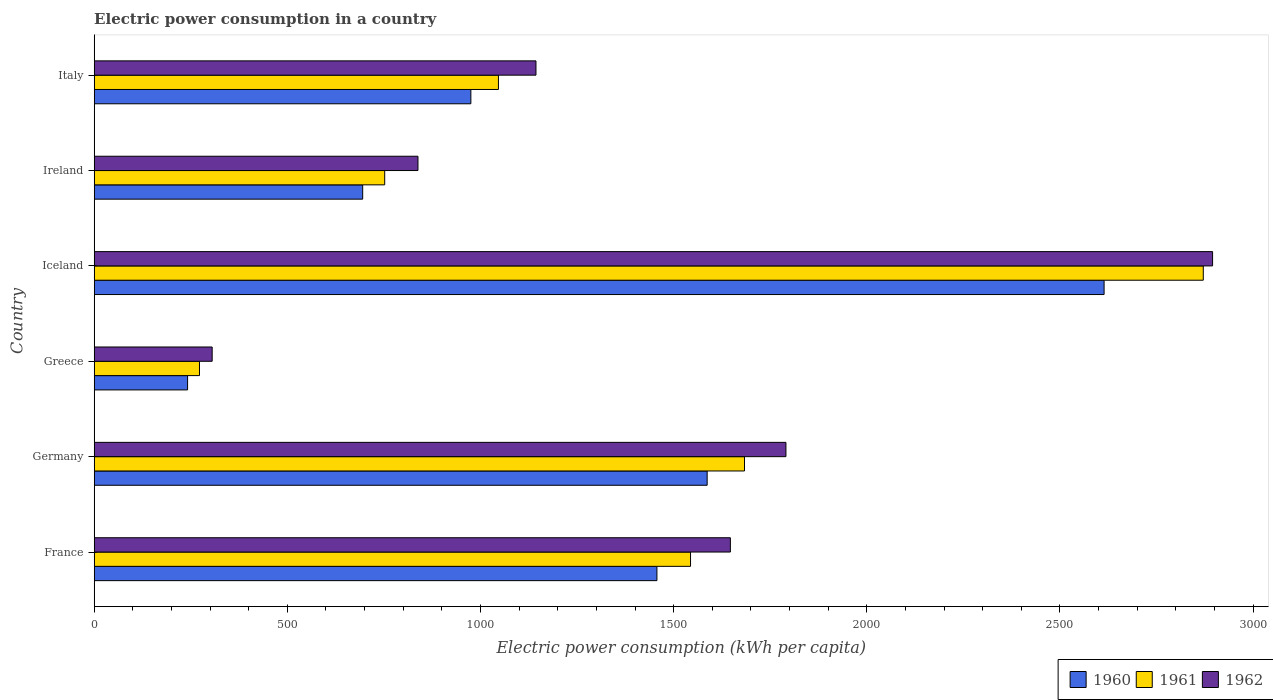How many different coloured bars are there?
Provide a short and direct response. 3. How many groups of bars are there?
Provide a succinct answer. 6. Are the number of bars per tick equal to the number of legend labels?
Offer a very short reply. Yes. How many bars are there on the 3rd tick from the top?
Give a very brief answer. 3. In how many cases, is the number of bars for a given country not equal to the number of legend labels?
Provide a short and direct response. 0. What is the electric power consumption in in 1962 in Italy?
Provide a short and direct response. 1143.61. Across all countries, what is the maximum electric power consumption in in 1961?
Your answer should be compact. 2871.04. Across all countries, what is the minimum electric power consumption in in 1960?
Make the answer very short. 241.73. In which country was the electric power consumption in in 1960 maximum?
Provide a short and direct response. Iceland. In which country was the electric power consumption in in 1961 minimum?
Give a very brief answer. Greece. What is the total electric power consumption in in 1960 in the graph?
Make the answer very short. 7569.52. What is the difference between the electric power consumption in in 1962 in Iceland and that in Italy?
Provide a short and direct response. 1751.48. What is the difference between the electric power consumption in in 1960 in Iceland and the electric power consumption in in 1962 in France?
Your answer should be very brief. 967.45. What is the average electric power consumption in in 1961 per country?
Your answer should be compact. 1361.53. What is the difference between the electric power consumption in in 1962 and electric power consumption in in 1960 in Iceland?
Provide a succinct answer. 280.8. What is the ratio of the electric power consumption in in 1961 in Greece to that in Ireland?
Keep it short and to the point. 0.36. Is the electric power consumption in in 1960 in Greece less than that in Ireland?
Give a very brief answer. Yes. What is the difference between the highest and the second highest electric power consumption in in 1962?
Keep it short and to the point. 1104.4. What is the difference between the highest and the lowest electric power consumption in in 1961?
Give a very brief answer. 2598.48. Is the sum of the electric power consumption in in 1961 in Iceland and Ireland greater than the maximum electric power consumption in in 1960 across all countries?
Provide a short and direct response. Yes. What does the 1st bar from the bottom in Italy represents?
Give a very brief answer. 1960. Is it the case that in every country, the sum of the electric power consumption in in 1960 and electric power consumption in in 1961 is greater than the electric power consumption in in 1962?
Give a very brief answer. Yes. How many bars are there?
Your answer should be very brief. 18. Are all the bars in the graph horizontal?
Your answer should be compact. Yes. How many countries are there in the graph?
Ensure brevity in your answer.  6. Does the graph contain any zero values?
Your response must be concise. No. How many legend labels are there?
Your answer should be compact. 3. What is the title of the graph?
Offer a terse response. Electric power consumption in a country. What is the label or title of the X-axis?
Your answer should be very brief. Electric power consumption (kWh per capita). What is the label or title of the Y-axis?
Make the answer very short. Country. What is the Electric power consumption (kWh per capita) in 1960 in France?
Give a very brief answer. 1456.69. What is the Electric power consumption (kWh per capita) in 1961 in France?
Make the answer very short. 1543.71. What is the Electric power consumption (kWh per capita) in 1962 in France?
Ensure brevity in your answer.  1646.83. What is the Electric power consumption (kWh per capita) in 1960 in Germany?
Offer a terse response. 1586.75. What is the Electric power consumption (kWh per capita) of 1961 in Germany?
Make the answer very short. 1683.41. What is the Electric power consumption (kWh per capita) in 1962 in Germany?
Give a very brief answer. 1790.69. What is the Electric power consumption (kWh per capita) in 1960 in Greece?
Your response must be concise. 241.73. What is the Electric power consumption (kWh per capita) of 1961 in Greece?
Your answer should be very brief. 272.56. What is the Electric power consumption (kWh per capita) of 1962 in Greece?
Your response must be concise. 305.39. What is the Electric power consumption (kWh per capita) in 1960 in Iceland?
Provide a short and direct response. 2614.28. What is the Electric power consumption (kWh per capita) of 1961 in Iceland?
Provide a short and direct response. 2871.04. What is the Electric power consumption (kWh per capita) in 1962 in Iceland?
Make the answer very short. 2895.09. What is the Electric power consumption (kWh per capita) in 1960 in Ireland?
Ensure brevity in your answer.  695.04. What is the Electric power consumption (kWh per capita) of 1961 in Ireland?
Keep it short and to the point. 752.02. What is the Electric power consumption (kWh per capita) in 1962 in Ireland?
Provide a short and direct response. 838.14. What is the Electric power consumption (kWh per capita) of 1960 in Italy?
Provide a short and direct response. 975.03. What is the Electric power consumption (kWh per capita) in 1961 in Italy?
Your answer should be compact. 1046.42. What is the Electric power consumption (kWh per capita) of 1962 in Italy?
Provide a succinct answer. 1143.61. Across all countries, what is the maximum Electric power consumption (kWh per capita) of 1960?
Offer a very short reply. 2614.28. Across all countries, what is the maximum Electric power consumption (kWh per capita) in 1961?
Ensure brevity in your answer.  2871.04. Across all countries, what is the maximum Electric power consumption (kWh per capita) of 1962?
Your answer should be compact. 2895.09. Across all countries, what is the minimum Electric power consumption (kWh per capita) of 1960?
Provide a succinct answer. 241.73. Across all countries, what is the minimum Electric power consumption (kWh per capita) in 1961?
Your response must be concise. 272.56. Across all countries, what is the minimum Electric power consumption (kWh per capita) in 1962?
Offer a terse response. 305.39. What is the total Electric power consumption (kWh per capita) in 1960 in the graph?
Your answer should be compact. 7569.52. What is the total Electric power consumption (kWh per capita) of 1961 in the graph?
Provide a succinct answer. 8169.17. What is the total Electric power consumption (kWh per capita) of 1962 in the graph?
Your answer should be very brief. 8619.74. What is the difference between the Electric power consumption (kWh per capita) in 1960 in France and that in Germany?
Your response must be concise. -130.06. What is the difference between the Electric power consumption (kWh per capita) in 1961 in France and that in Germany?
Your response must be concise. -139.7. What is the difference between the Electric power consumption (kWh per capita) of 1962 in France and that in Germany?
Offer a very short reply. -143.85. What is the difference between the Electric power consumption (kWh per capita) in 1960 in France and that in Greece?
Ensure brevity in your answer.  1214.97. What is the difference between the Electric power consumption (kWh per capita) of 1961 in France and that in Greece?
Offer a terse response. 1271.15. What is the difference between the Electric power consumption (kWh per capita) in 1962 in France and that in Greece?
Your response must be concise. 1341.44. What is the difference between the Electric power consumption (kWh per capita) of 1960 in France and that in Iceland?
Give a very brief answer. -1157.59. What is the difference between the Electric power consumption (kWh per capita) of 1961 in France and that in Iceland?
Provide a succinct answer. -1327.33. What is the difference between the Electric power consumption (kWh per capita) of 1962 in France and that in Iceland?
Give a very brief answer. -1248.25. What is the difference between the Electric power consumption (kWh per capita) in 1960 in France and that in Ireland?
Give a very brief answer. 761.65. What is the difference between the Electric power consumption (kWh per capita) of 1961 in France and that in Ireland?
Provide a succinct answer. 791.69. What is the difference between the Electric power consumption (kWh per capita) in 1962 in France and that in Ireland?
Provide a short and direct response. 808.69. What is the difference between the Electric power consumption (kWh per capita) in 1960 in France and that in Italy?
Make the answer very short. 481.67. What is the difference between the Electric power consumption (kWh per capita) in 1961 in France and that in Italy?
Your answer should be very brief. 497.3. What is the difference between the Electric power consumption (kWh per capita) of 1962 in France and that in Italy?
Offer a very short reply. 503.23. What is the difference between the Electric power consumption (kWh per capita) of 1960 in Germany and that in Greece?
Offer a terse response. 1345.02. What is the difference between the Electric power consumption (kWh per capita) of 1961 in Germany and that in Greece?
Make the answer very short. 1410.85. What is the difference between the Electric power consumption (kWh per capita) of 1962 in Germany and that in Greece?
Provide a short and direct response. 1485.3. What is the difference between the Electric power consumption (kWh per capita) in 1960 in Germany and that in Iceland?
Make the answer very short. -1027.53. What is the difference between the Electric power consumption (kWh per capita) of 1961 in Germany and that in Iceland?
Keep it short and to the point. -1187.63. What is the difference between the Electric power consumption (kWh per capita) in 1962 in Germany and that in Iceland?
Give a very brief answer. -1104.4. What is the difference between the Electric power consumption (kWh per capita) in 1960 in Germany and that in Ireland?
Provide a short and direct response. 891.71. What is the difference between the Electric power consumption (kWh per capita) of 1961 in Germany and that in Ireland?
Give a very brief answer. 931.4. What is the difference between the Electric power consumption (kWh per capita) in 1962 in Germany and that in Ireland?
Make the answer very short. 952.55. What is the difference between the Electric power consumption (kWh per capita) of 1960 in Germany and that in Italy?
Ensure brevity in your answer.  611.72. What is the difference between the Electric power consumption (kWh per capita) in 1961 in Germany and that in Italy?
Your response must be concise. 637. What is the difference between the Electric power consumption (kWh per capita) in 1962 in Germany and that in Italy?
Your response must be concise. 647.08. What is the difference between the Electric power consumption (kWh per capita) of 1960 in Greece and that in Iceland?
Your answer should be compact. -2372.56. What is the difference between the Electric power consumption (kWh per capita) in 1961 in Greece and that in Iceland?
Provide a short and direct response. -2598.48. What is the difference between the Electric power consumption (kWh per capita) of 1962 in Greece and that in Iceland?
Ensure brevity in your answer.  -2589.7. What is the difference between the Electric power consumption (kWh per capita) of 1960 in Greece and that in Ireland?
Offer a very short reply. -453.32. What is the difference between the Electric power consumption (kWh per capita) in 1961 in Greece and that in Ireland?
Offer a very short reply. -479.45. What is the difference between the Electric power consumption (kWh per capita) in 1962 in Greece and that in Ireland?
Your answer should be very brief. -532.75. What is the difference between the Electric power consumption (kWh per capita) in 1960 in Greece and that in Italy?
Offer a terse response. -733.3. What is the difference between the Electric power consumption (kWh per capita) of 1961 in Greece and that in Italy?
Give a very brief answer. -773.85. What is the difference between the Electric power consumption (kWh per capita) in 1962 in Greece and that in Italy?
Ensure brevity in your answer.  -838.22. What is the difference between the Electric power consumption (kWh per capita) in 1960 in Iceland and that in Ireland?
Your response must be concise. 1919.24. What is the difference between the Electric power consumption (kWh per capita) of 1961 in Iceland and that in Ireland?
Keep it short and to the point. 2119.03. What is the difference between the Electric power consumption (kWh per capita) of 1962 in Iceland and that in Ireland?
Your response must be concise. 2056.95. What is the difference between the Electric power consumption (kWh per capita) in 1960 in Iceland and that in Italy?
Give a very brief answer. 1639.26. What is the difference between the Electric power consumption (kWh per capita) of 1961 in Iceland and that in Italy?
Offer a very short reply. 1824.63. What is the difference between the Electric power consumption (kWh per capita) in 1962 in Iceland and that in Italy?
Your response must be concise. 1751.48. What is the difference between the Electric power consumption (kWh per capita) in 1960 in Ireland and that in Italy?
Your response must be concise. -279.98. What is the difference between the Electric power consumption (kWh per capita) of 1961 in Ireland and that in Italy?
Provide a succinct answer. -294.4. What is the difference between the Electric power consumption (kWh per capita) in 1962 in Ireland and that in Italy?
Your response must be concise. -305.47. What is the difference between the Electric power consumption (kWh per capita) of 1960 in France and the Electric power consumption (kWh per capita) of 1961 in Germany?
Offer a terse response. -226.72. What is the difference between the Electric power consumption (kWh per capita) of 1960 in France and the Electric power consumption (kWh per capita) of 1962 in Germany?
Give a very brief answer. -333.99. What is the difference between the Electric power consumption (kWh per capita) in 1961 in France and the Electric power consumption (kWh per capita) in 1962 in Germany?
Make the answer very short. -246.98. What is the difference between the Electric power consumption (kWh per capita) of 1960 in France and the Electric power consumption (kWh per capita) of 1961 in Greece?
Offer a terse response. 1184.13. What is the difference between the Electric power consumption (kWh per capita) in 1960 in France and the Electric power consumption (kWh per capita) in 1962 in Greece?
Make the answer very short. 1151.3. What is the difference between the Electric power consumption (kWh per capita) in 1961 in France and the Electric power consumption (kWh per capita) in 1962 in Greece?
Offer a very short reply. 1238.32. What is the difference between the Electric power consumption (kWh per capita) of 1960 in France and the Electric power consumption (kWh per capita) of 1961 in Iceland?
Keep it short and to the point. -1414.35. What is the difference between the Electric power consumption (kWh per capita) of 1960 in France and the Electric power consumption (kWh per capita) of 1962 in Iceland?
Ensure brevity in your answer.  -1438.39. What is the difference between the Electric power consumption (kWh per capita) of 1961 in France and the Electric power consumption (kWh per capita) of 1962 in Iceland?
Offer a very short reply. -1351.37. What is the difference between the Electric power consumption (kWh per capita) in 1960 in France and the Electric power consumption (kWh per capita) in 1961 in Ireland?
Ensure brevity in your answer.  704.68. What is the difference between the Electric power consumption (kWh per capita) in 1960 in France and the Electric power consumption (kWh per capita) in 1962 in Ireland?
Give a very brief answer. 618.56. What is the difference between the Electric power consumption (kWh per capita) of 1961 in France and the Electric power consumption (kWh per capita) of 1962 in Ireland?
Provide a short and direct response. 705.57. What is the difference between the Electric power consumption (kWh per capita) in 1960 in France and the Electric power consumption (kWh per capita) in 1961 in Italy?
Make the answer very short. 410.28. What is the difference between the Electric power consumption (kWh per capita) of 1960 in France and the Electric power consumption (kWh per capita) of 1962 in Italy?
Your answer should be very brief. 313.09. What is the difference between the Electric power consumption (kWh per capita) in 1961 in France and the Electric power consumption (kWh per capita) in 1962 in Italy?
Your answer should be compact. 400.11. What is the difference between the Electric power consumption (kWh per capita) in 1960 in Germany and the Electric power consumption (kWh per capita) in 1961 in Greece?
Provide a short and direct response. 1314.19. What is the difference between the Electric power consumption (kWh per capita) in 1960 in Germany and the Electric power consumption (kWh per capita) in 1962 in Greece?
Offer a very short reply. 1281.36. What is the difference between the Electric power consumption (kWh per capita) in 1961 in Germany and the Electric power consumption (kWh per capita) in 1962 in Greece?
Make the answer very short. 1378.03. What is the difference between the Electric power consumption (kWh per capita) of 1960 in Germany and the Electric power consumption (kWh per capita) of 1961 in Iceland?
Make the answer very short. -1284.29. What is the difference between the Electric power consumption (kWh per capita) of 1960 in Germany and the Electric power consumption (kWh per capita) of 1962 in Iceland?
Keep it short and to the point. -1308.34. What is the difference between the Electric power consumption (kWh per capita) of 1961 in Germany and the Electric power consumption (kWh per capita) of 1962 in Iceland?
Your response must be concise. -1211.67. What is the difference between the Electric power consumption (kWh per capita) of 1960 in Germany and the Electric power consumption (kWh per capita) of 1961 in Ireland?
Make the answer very short. 834.73. What is the difference between the Electric power consumption (kWh per capita) of 1960 in Germany and the Electric power consumption (kWh per capita) of 1962 in Ireland?
Offer a terse response. 748.61. What is the difference between the Electric power consumption (kWh per capita) of 1961 in Germany and the Electric power consumption (kWh per capita) of 1962 in Ireland?
Offer a terse response. 845.28. What is the difference between the Electric power consumption (kWh per capita) in 1960 in Germany and the Electric power consumption (kWh per capita) in 1961 in Italy?
Your answer should be very brief. 540.33. What is the difference between the Electric power consumption (kWh per capita) in 1960 in Germany and the Electric power consumption (kWh per capita) in 1962 in Italy?
Provide a short and direct response. 443.14. What is the difference between the Electric power consumption (kWh per capita) of 1961 in Germany and the Electric power consumption (kWh per capita) of 1962 in Italy?
Offer a very short reply. 539.81. What is the difference between the Electric power consumption (kWh per capita) in 1960 in Greece and the Electric power consumption (kWh per capita) in 1961 in Iceland?
Offer a terse response. -2629.32. What is the difference between the Electric power consumption (kWh per capita) in 1960 in Greece and the Electric power consumption (kWh per capita) in 1962 in Iceland?
Provide a succinct answer. -2653.36. What is the difference between the Electric power consumption (kWh per capita) in 1961 in Greece and the Electric power consumption (kWh per capita) in 1962 in Iceland?
Provide a short and direct response. -2622.52. What is the difference between the Electric power consumption (kWh per capita) of 1960 in Greece and the Electric power consumption (kWh per capita) of 1961 in Ireland?
Keep it short and to the point. -510.29. What is the difference between the Electric power consumption (kWh per capita) in 1960 in Greece and the Electric power consumption (kWh per capita) in 1962 in Ireland?
Offer a terse response. -596.41. What is the difference between the Electric power consumption (kWh per capita) of 1961 in Greece and the Electric power consumption (kWh per capita) of 1962 in Ireland?
Offer a terse response. -565.57. What is the difference between the Electric power consumption (kWh per capita) in 1960 in Greece and the Electric power consumption (kWh per capita) in 1961 in Italy?
Give a very brief answer. -804.69. What is the difference between the Electric power consumption (kWh per capita) in 1960 in Greece and the Electric power consumption (kWh per capita) in 1962 in Italy?
Offer a very short reply. -901.88. What is the difference between the Electric power consumption (kWh per capita) of 1961 in Greece and the Electric power consumption (kWh per capita) of 1962 in Italy?
Ensure brevity in your answer.  -871.04. What is the difference between the Electric power consumption (kWh per capita) in 1960 in Iceland and the Electric power consumption (kWh per capita) in 1961 in Ireland?
Offer a terse response. 1862.26. What is the difference between the Electric power consumption (kWh per capita) of 1960 in Iceland and the Electric power consumption (kWh per capita) of 1962 in Ireland?
Offer a terse response. 1776.14. What is the difference between the Electric power consumption (kWh per capita) of 1961 in Iceland and the Electric power consumption (kWh per capita) of 1962 in Ireland?
Keep it short and to the point. 2032.91. What is the difference between the Electric power consumption (kWh per capita) of 1960 in Iceland and the Electric power consumption (kWh per capita) of 1961 in Italy?
Keep it short and to the point. 1567.87. What is the difference between the Electric power consumption (kWh per capita) of 1960 in Iceland and the Electric power consumption (kWh per capita) of 1962 in Italy?
Provide a short and direct response. 1470.68. What is the difference between the Electric power consumption (kWh per capita) of 1961 in Iceland and the Electric power consumption (kWh per capita) of 1962 in Italy?
Offer a very short reply. 1727.44. What is the difference between the Electric power consumption (kWh per capita) in 1960 in Ireland and the Electric power consumption (kWh per capita) in 1961 in Italy?
Your answer should be very brief. -351.37. What is the difference between the Electric power consumption (kWh per capita) of 1960 in Ireland and the Electric power consumption (kWh per capita) of 1962 in Italy?
Provide a succinct answer. -448.56. What is the difference between the Electric power consumption (kWh per capita) of 1961 in Ireland and the Electric power consumption (kWh per capita) of 1962 in Italy?
Your answer should be compact. -391.59. What is the average Electric power consumption (kWh per capita) of 1960 per country?
Provide a short and direct response. 1261.59. What is the average Electric power consumption (kWh per capita) of 1961 per country?
Keep it short and to the point. 1361.53. What is the average Electric power consumption (kWh per capita) of 1962 per country?
Your answer should be compact. 1436.62. What is the difference between the Electric power consumption (kWh per capita) in 1960 and Electric power consumption (kWh per capita) in 1961 in France?
Ensure brevity in your answer.  -87.02. What is the difference between the Electric power consumption (kWh per capita) in 1960 and Electric power consumption (kWh per capita) in 1962 in France?
Your answer should be compact. -190.14. What is the difference between the Electric power consumption (kWh per capita) of 1961 and Electric power consumption (kWh per capita) of 1962 in France?
Your answer should be very brief. -103.12. What is the difference between the Electric power consumption (kWh per capita) in 1960 and Electric power consumption (kWh per capita) in 1961 in Germany?
Provide a short and direct response. -96.67. What is the difference between the Electric power consumption (kWh per capita) in 1960 and Electric power consumption (kWh per capita) in 1962 in Germany?
Your answer should be very brief. -203.94. What is the difference between the Electric power consumption (kWh per capita) of 1961 and Electric power consumption (kWh per capita) of 1962 in Germany?
Your response must be concise. -107.27. What is the difference between the Electric power consumption (kWh per capita) of 1960 and Electric power consumption (kWh per capita) of 1961 in Greece?
Provide a succinct answer. -30.84. What is the difference between the Electric power consumption (kWh per capita) of 1960 and Electric power consumption (kWh per capita) of 1962 in Greece?
Your answer should be very brief. -63.66. What is the difference between the Electric power consumption (kWh per capita) of 1961 and Electric power consumption (kWh per capita) of 1962 in Greece?
Offer a terse response. -32.83. What is the difference between the Electric power consumption (kWh per capita) in 1960 and Electric power consumption (kWh per capita) in 1961 in Iceland?
Provide a short and direct response. -256.76. What is the difference between the Electric power consumption (kWh per capita) in 1960 and Electric power consumption (kWh per capita) in 1962 in Iceland?
Offer a very short reply. -280.8. What is the difference between the Electric power consumption (kWh per capita) of 1961 and Electric power consumption (kWh per capita) of 1962 in Iceland?
Make the answer very short. -24.04. What is the difference between the Electric power consumption (kWh per capita) in 1960 and Electric power consumption (kWh per capita) in 1961 in Ireland?
Your answer should be very brief. -56.97. What is the difference between the Electric power consumption (kWh per capita) in 1960 and Electric power consumption (kWh per capita) in 1962 in Ireland?
Give a very brief answer. -143.09. What is the difference between the Electric power consumption (kWh per capita) in 1961 and Electric power consumption (kWh per capita) in 1962 in Ireland?
Offer a very short reply. -86.12. What is the difference between the Electric power consumption (kWh per capita) in 1960 and Electric power consumption (kWh per capita) in 1961 in Italy?
Ensure brevity in your answer.  -71.39. What is the difference between the Electric power consumption (kWh per capita) in 1960 and Electric power consumption (kWh per capita) in 1962 in Italy?
Your answer should be very brief. -168.58. What is the difference between the Electric power consumption (kWh per capita) of 1961 and Electric power consumption (kWh per capita) of 1962 in Italy?
Ensure brevity in your answer.  -97.19. What is the ratio of the Electric power consumption (kWh per capita) in 1960 in France to that in Germany?
Offer a very short reply. 0.92. What is the ratio of the Electric power consumption (kWh per capita) in 1961 in France to that in Germany?
Give a very brief answer. 0.92. What is the ratio of the Electric power consumption (kWh per capita) in 1962 in France to that in Germany?
Provide a short and direct response. 0.92. What is the ratio of the Electric power consumption (kWh per capita) in 1960 in France to that in Greece?
Offer a very short reply. 6.03. What is the ratio of the Electric power consumption (kWh per capita) in 1961 in France to that in Greece?
Make the answer very short. 5.66. What is the ratio of the Electric power consumption (kWh per capita) of 1962 in France to that in Greece?
Give a very brief answer. 5.39. What is the ratio of the Electric power consumption (kWh per capita) of 1960 in France to that in Iceland?
Provide a short and direct response. 0.56. What is the ratio of the Electric power consumption (kWh per capita) in 1961 in France to that in Iceland?
Provide a succinct answer. 0.54. What is the ratio of the Electric power consumption (kWh per capita) of 1962 in France to that in Iceland?
Your response must be concise. 0.57. What is the ratio of the Electric power consumption (kWh per capita) of 1960 in France to that in Ireland?
Provide a short and direct response. 2.1. What is the ratio of the Electric power consumption (kWh per capita) of 1961 in France to that in Ireland?
Give a very brief answer. 2.05. What is the ratio of the Electric power consumption (kWh per capita) in 1962 in France to that in Ireland?
Your response must be concise. 1.96. What is the ratio of the Electric power consumption (kWh per capita) of 1960 in France to that in Italy?
Provide a succinct answer. 1.49. What is the ratio of the Electric power consumption (kWh per capita) in 1961 in France to that in Italy?
Offer a very short reply. 1.48. What is the ratio of the Electric power consumption (kWh per capita) in 1962 in France to that in Italy?
Ensure brevity in your answer.  1.44. What is the ratio of the Electric power consumption (kWh per capita) of 1960 in Germany to that in Greece?
Offer a terse response. 6.56. What is the ratio of the Electric power consumption (kWh per capita) of 1961 in Germany to that in Greece?
Make the answer very short. 6.18. What is the ratio of the Electric power consumption (kWh per capita) of 1962 in Germany to that in Greece?
Give a very brief answer. 5.86. What is the ratio of the Electric power consumption (kWh per capita) of 1960 in Germany to that in Iceland?
Provide a succinct answer. 0.61. What is the ratio of the Electric power consumption (kWh per capita) of 1961 in Germany to that in Iceland?
Give a very brief answer. 0.59. What is the ratio of the Electric power consumption (kWh per capita) of 1962 in Germany to that in Iceland?
Make the answer very short. 0.62. What is the ratio of the Electric power consumption (kWh per capita) of 1960 in Germany to that in Ireland?
Give a very brief answer. 2.28. What is the ratio of the Electric power consumption (kWh per capita) in 1961 in Germany to that in Ireland?
Your answer should be very brief. 2.24. What is the ratio of the Electric power consumption (kWh per capita) of 1962 in Germany to that in Ireland?
Offer a terse response. 2.14. What is the ratio of the Electric power consumption (kWh per capita) of 1960 in Germany to that in Italy?
Give a very brief answer. 1.63. What is the ratio of the Electric power consumption (kWh per capita) in 1961 in Germany to that in Italy?
Give a very brief answer. 1.61. What is the ratio of the Electric power consumption (kWh per capita) in 1962 in Germany to that in Italy?
Make the answer very short. 1.57. What is the ratio of the Electric power consumption (kWh per capita) in 1960 in Greece to that in Iceland?
Offer a very short reply. 0.09. What is the ratio of the Electric power consumption (kWh per capita) of 1961 in Greece to that in Iceland?
Ensure brevity in your answer.  0.09. What is the ratio of the Electric power consumption (kWh per capita) in 1962 in Greece to that in Iceland?
Your answer should be very brief. 0.11. What is the ratio of the Electric power consumption (kWh per capita) in 1960 in Greece to that in Ireland?
Keep it short and to the point. 0.35. What is the ratio of the Electric power consumption (kWh per capita) of 1961 in Greece to that in Ireland?
Give a very brief answer. 0.36. What is the ratio of the Electric power consumption (kWh per capita) of 1962 in Greece to that in Ireland?
Offer a very short reply. 0.36. What is the ratio of the Electric power consumption (kWh per capita) in 1960 in Greece to that in Italy?
Provide a succinct answer. 0.25. What is the ratio of the Electric power consumption (kWh per capita) of 1961 in Greece to that in Italy?
Your response must be concise. 0.26. What is the ratio of the Electric power consumption (kWh per capita) of 1962 in Greece to that in Italy?
Make the answer very short. 0.27. What is the ratio of the Electric power consumption (kWh per capita) of 1960 in Iceland to that in Ireland?
Provide a short and direct response. 3.76. What is the ratio of the Electric power consumption (kWh per capita) in 1961 in Iceland to that in Ireland?
Provide a short and direct response. 3.82. What is the ratio of the Electric power consumption (kWh per capita) of 1962 in Iceland to that in Ireland?
Keep it short and to the point. 3.45. What is the ratio of the Electric power consumption (kWh per capita) in 1960 in Iceland to that in Italy?
Your answer should be compact. 2.68. What is the ratio of the Electric power consumption (kWh per capita) in 1961 in Iceland to that in Italy?
Make the answer very short. 2.74. What is the ratio of the Electric power consumption (kWh per capita) in 1962 in Iceland to that in Italy?
Make the answer very short. 2.53. What is the ratio of the Electric power consumption (kWh per capita) in 1960 in Ireland to that in Italy?
Provide a succinct answer. 0.71. What is the ratio of the Electric power consumption (kWh per capita) of 1961 in Ireland to that in Italy?
Keep it short and to the point. 0.72. What is the ratio of the Electric power consumption (kWh per capita) in 1962 in Ireland to that in Italy?
Provide a short and direct response. 0.73. What is the difference between the highest and the second highest Electric power consumption (kWh per capita) of 1960?
Your answer should be compact. 1027.53. What is the difference between the highest and the second highest Electric power consumption (kWh per capita) in 1961?
Your answer should be very brief. 1187.63. What is the difference between the highest and the second highest Electric power consumption (kWh per capita) in 1962?
Make the answer very short. 1104.4. What is the difference between the highest and the lowest Electric power consumption (kWh per capita) of 1960?
Keep it short and to the point. 2372.56. What is the difference between the highest and the lowest Electric power consumption (kWh per capita) of 1961?
Ensure brevity in your answer.  2598.48. What is the difference between the highest and the lowest Electric power consumption (kWh per capita) of 1962?
Provide a succinct answer. 2589.7. 